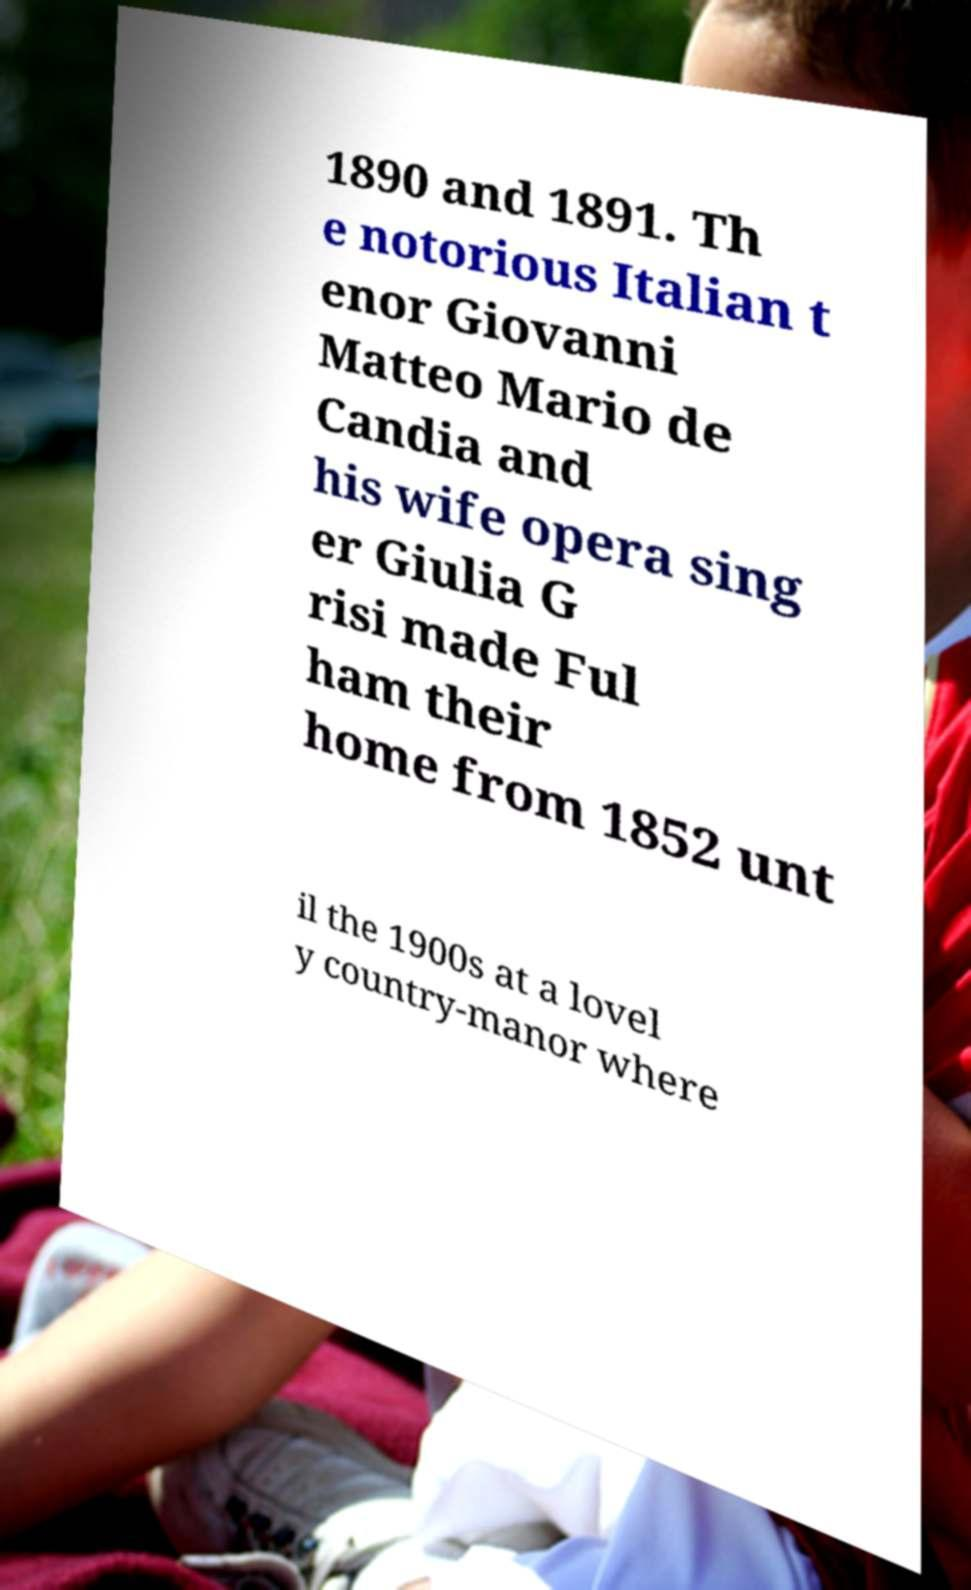There's text embedded in this image that I need extracted. Can you transcribe it verbatim? 1890 and 1891. Th e notorious Italian t enor Giovanni Matteo Mario de Candia and his wife opera sing er Giulia G risi made Ful ham their home from 1852 unt il the 1900s at a lovel y country-manor where 